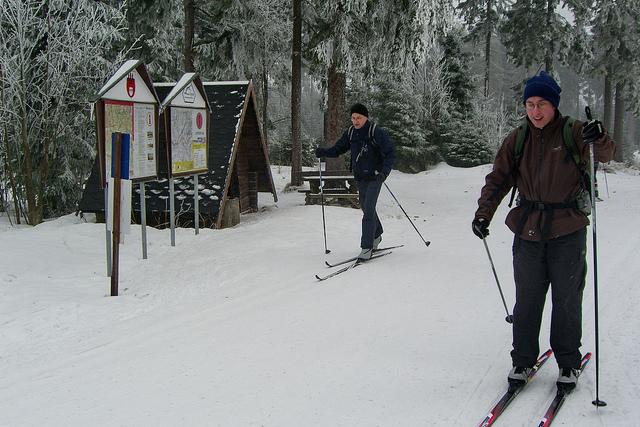What are they doing?
Be succinct. Skiing. Do they wearing hats?
Write a very short answer. Yes. Is the man on the right holding ski poles?
Keep it brief. Yes. 